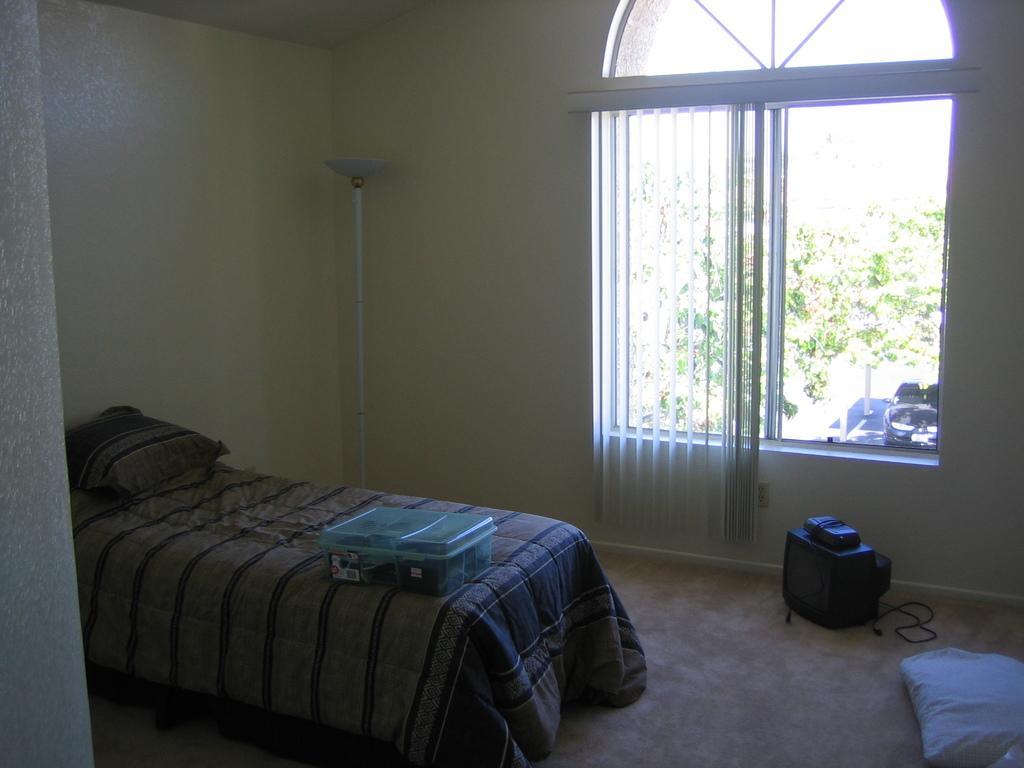Could you give a brief overview of what you see in this image? In this picture we can see a bed, here we can see a floor, pillows, box, television and some objects and in the background we can see a wall, window, trees, curtain and some objects. 